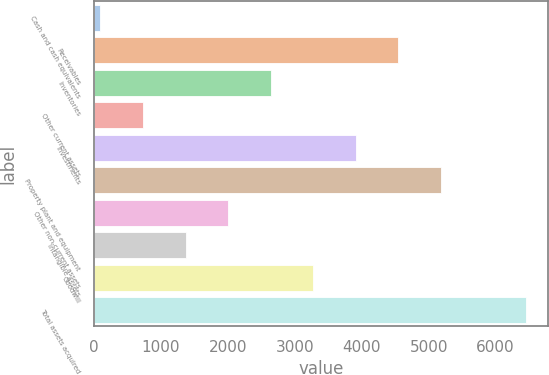Convert chart. <chart><loc_0><loc_0><loc_500><loc_500><bar_chart><fcel>Cash and cash equivalents<fcel>Receivables<fcel>Inventories<fcel>Other current assets<fcel>Investments<fcel>Property plant and equipment<fcel>Other non-current assets<fcel>Intangible assets<fcel>Goodwill<fcel>Total assets acquired<nl><fcel>93<fcel>4546.4<fcel>2637.8<fcel>729.2<fcel>3910.2<fcel>5182.6<fcel>2001.6<fcel>1365.4<fcel>3274<fcel>6455<nl></chart> 